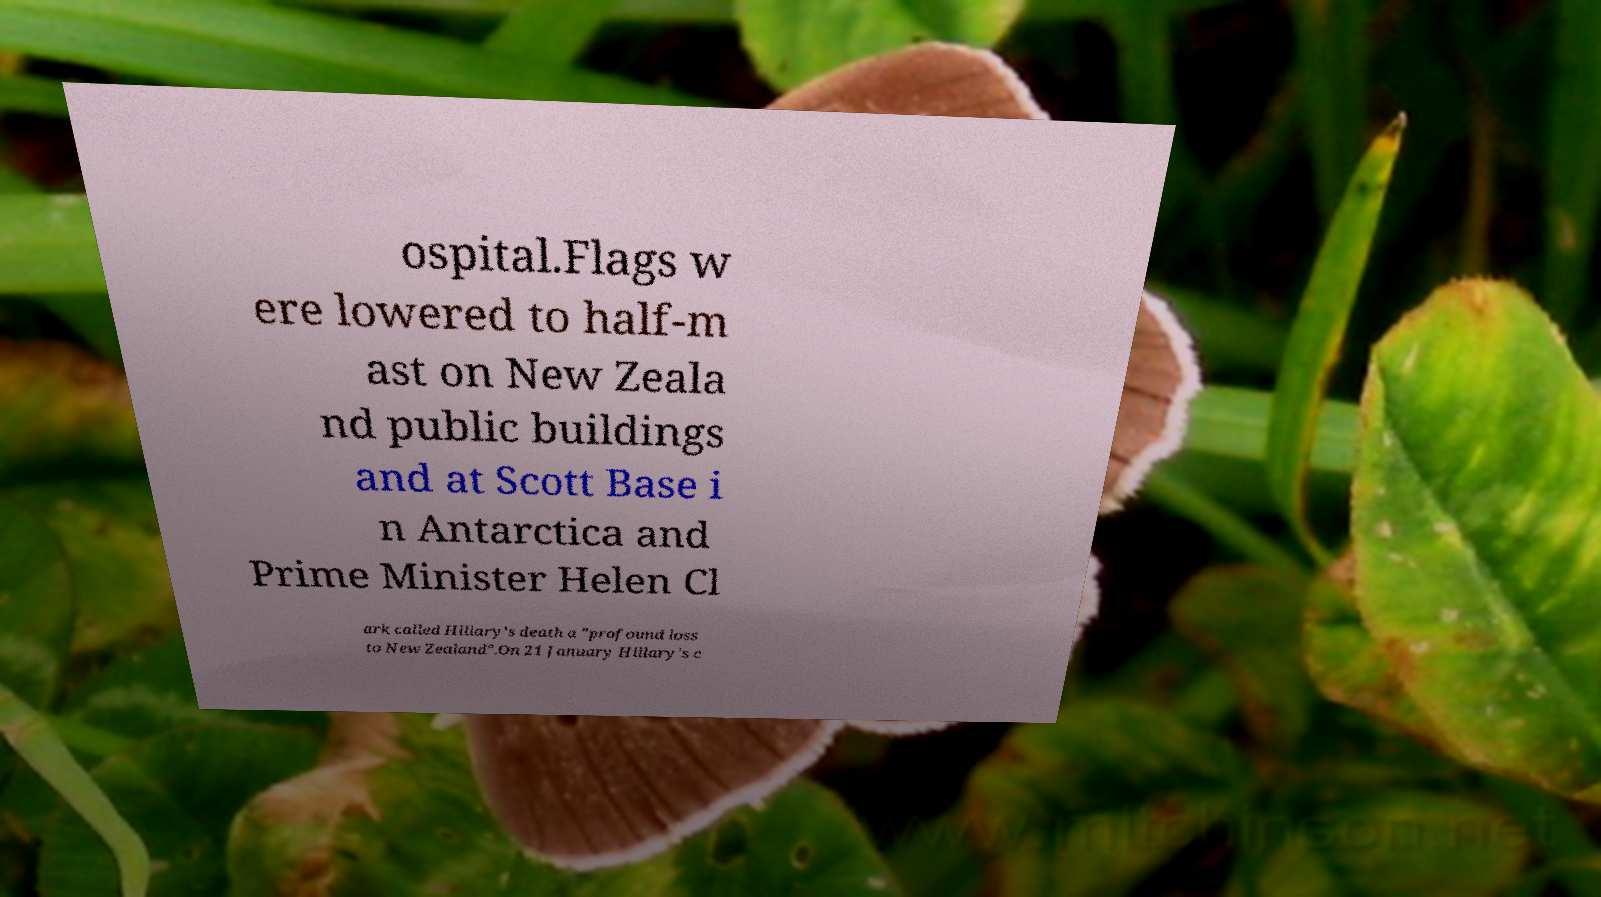Please read and relay the text visible in this image. What does it say? ospital.Flags w ere lowered to half-m ast on New Zeala nd public buildings and at Scott Base i n Antarctica and Prime Minister Helen Cl ark called Hillary's death a "profound loss to New Zealand".On 21 January Hillary's c 